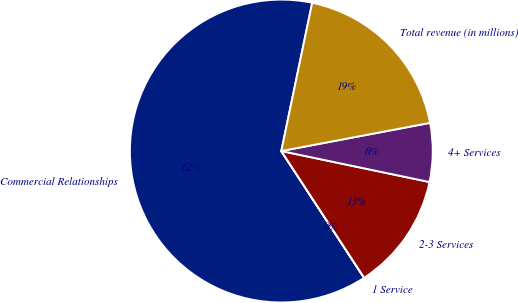<chart> <loc_0><loc_0><loc_500><loc_500><pie_chart><fcel>Commercial Relationships<fcel>1 Service<fcel>2-3 Services<fcel>4+ Services<fcel>Total revenue (in millions)<nl><fcel>62.47%<fcel>0.01%<fcel>12.5%<fcel>6.26%<fcel>18.75%<nl></chart> 